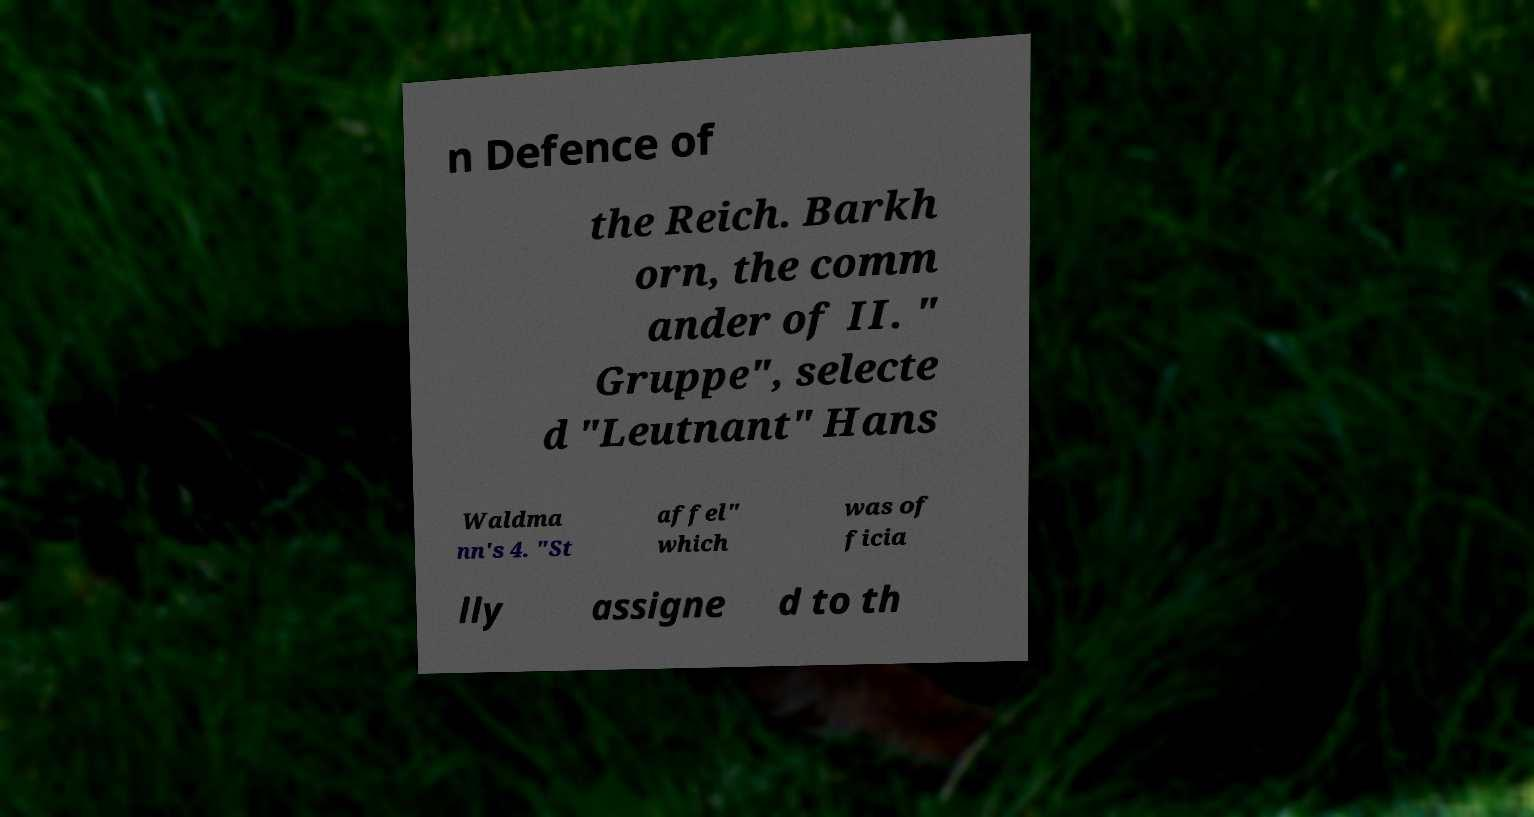Could you assist in decoding the text presented in this image and type it out clearly? n Defence of the Reich. Barkh orn, the comm ander of II. " Gruppe", selecte d "Leutnant" Hans Waldma nn's 4. "St affel" which was of ficia lly assigne d to th 